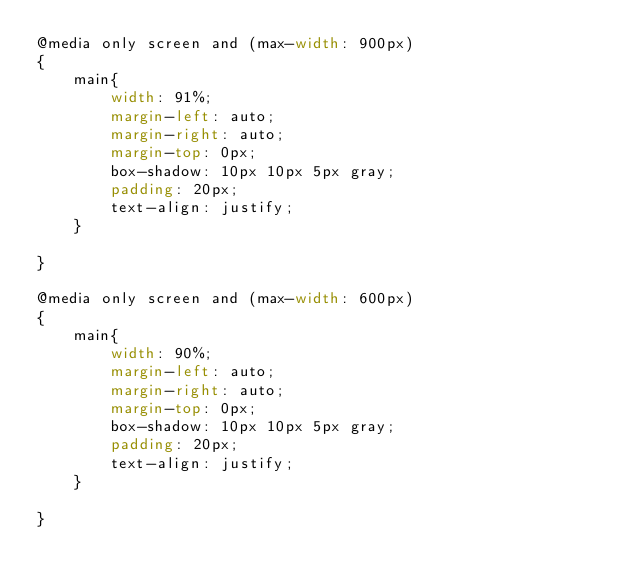<code> <loc_0><loc_0><loc_500><loc_500><_CSS_>@media only screen and (max-width: 900px)
{
    main{
        width: 91%;
        margin-left: auto;
        margin-right: auto;
        margin-top: 0px;
        box-shadow: 10px 10px 5px gray;
        padding: 20px;
        text-align: justify;
    }

}

@media only screen and (max-width: 600px)
{
    main{
        width: 90%;
        margin-left: auto;
        margin-right: auto;
        margin-top: 0px;
        box-shadow: 10px 10px 5px gray;
        padding: 20px;
        text-align: justify;
    }

}</code> 